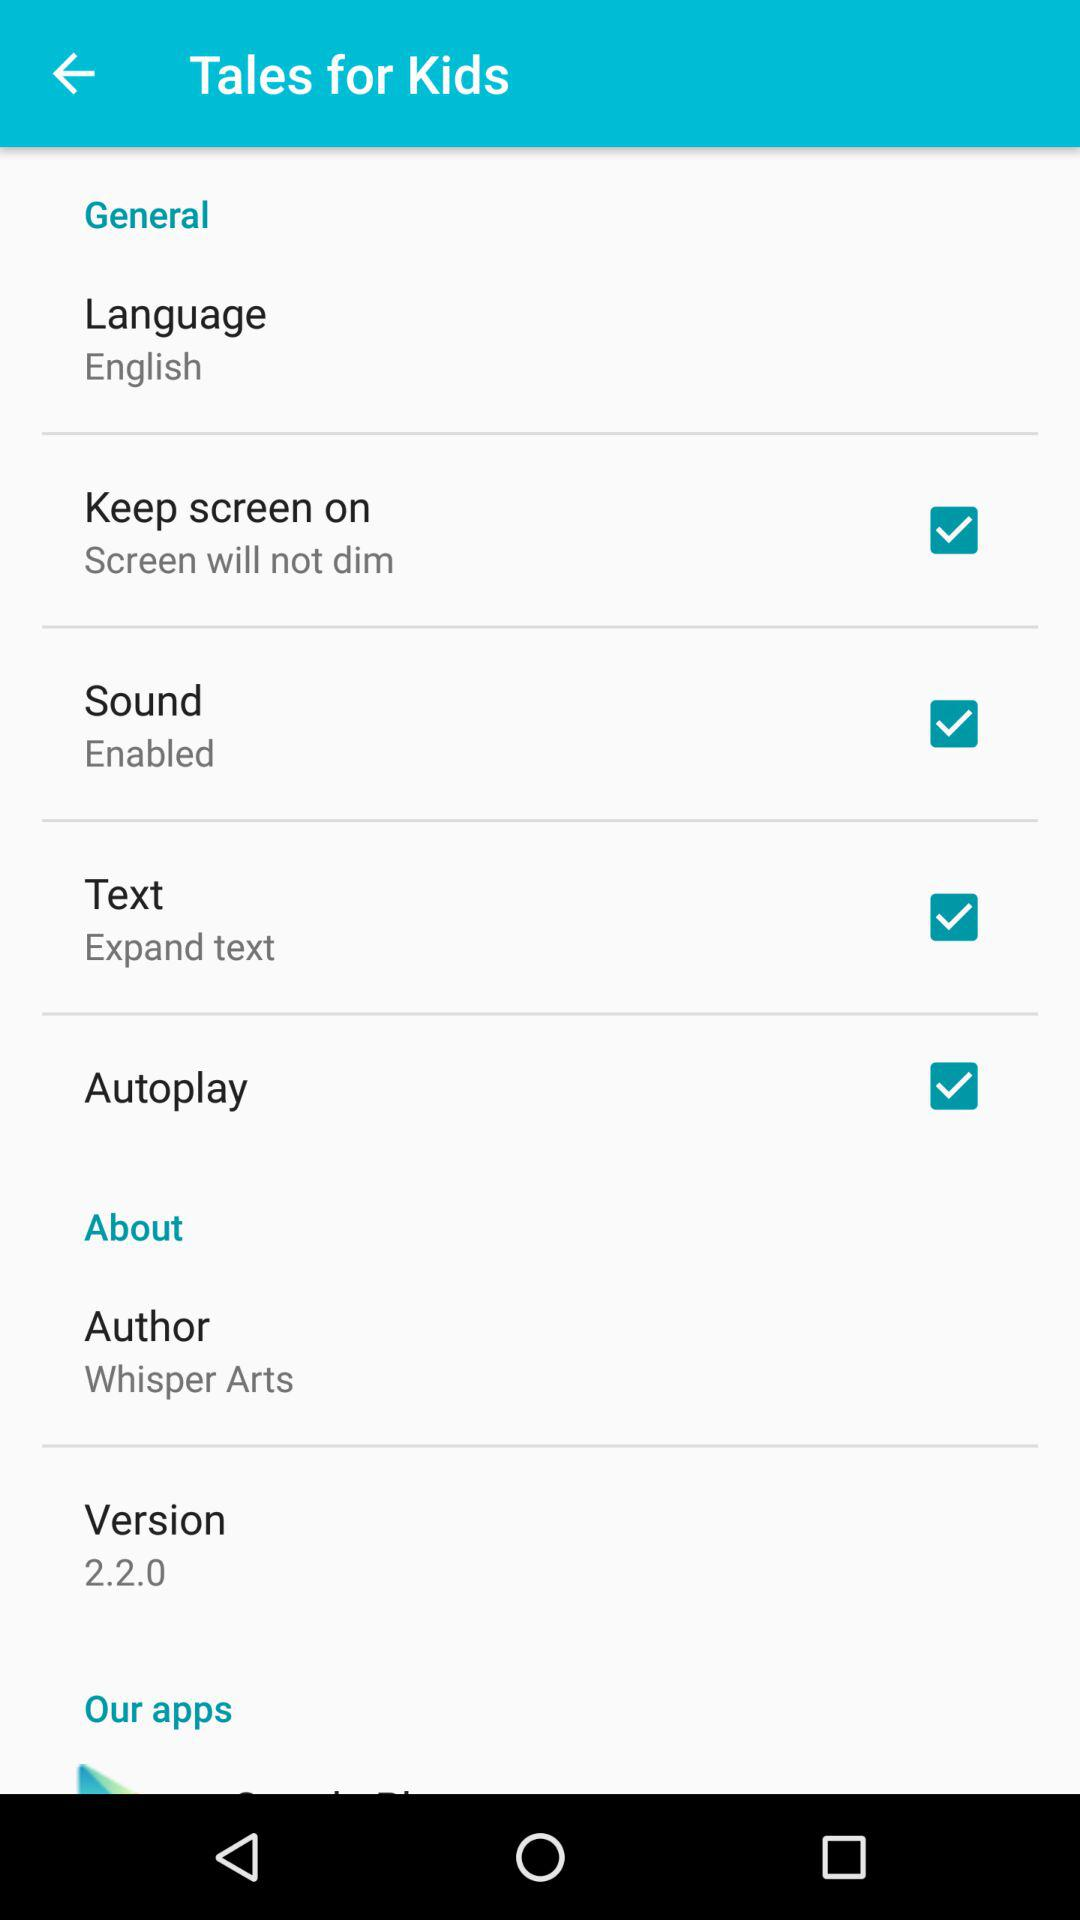What is the version? The version is 2.2.0. 